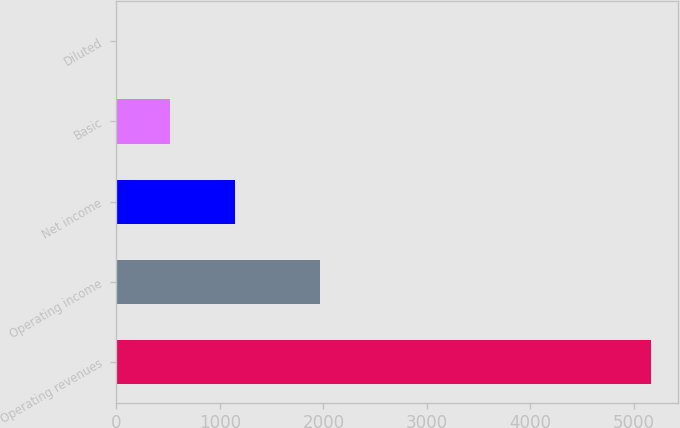<chart> <loc_0><loc_0><loc_500><loc_500><bar_chart><fcel>Operating revenues<fcel>Operating income<fcel>Net income<fcel>Basic<fcel>Diluted<nl><fcel>5168<fcel>1965<fcel>1144<fcel>518.05<fcel>1.39<nl></chart> 